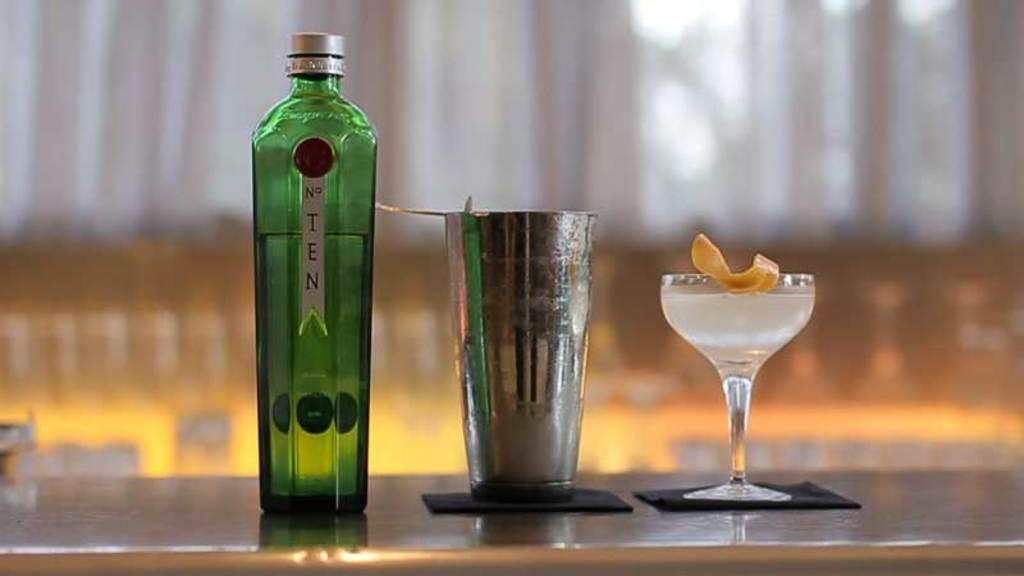<image>
Share a concise interpretation of the image provided. A Green bottle from the brand Ten with a glass near it. 